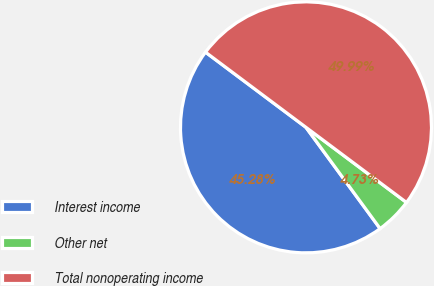<chart> <loc_0><loc_0><loc_500><loc_500><pie_chart><fcel>Interest income<fcel>Other net<fcel>Total nonoperating income<nl><fcel>45.28%<fcel>4.73%<fcel>49.99%<nl></chart> 